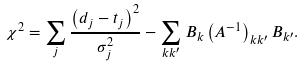Convert formula to latex. <formula><loc_0><loc_0><loc_500><loc_500>\chi ^ { 2 } = \sum _ { j } \frac { \left ( d _ { j } - t _ { j } \right ) ^ { 2 } } { \sigma _ { j } ^ { 2 } } - \sum _ { k k ^ { \prime } } B _ { k } \left ( A ^ { - 1 } \right ) _ { k k ^ { \prime } } B _ { k ^ { \prime } } .</formula> 